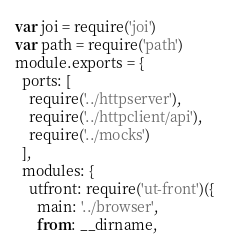Convert code to text. <code><loc_0><loc_0><loc_500><loc_500><_JavaScript_>var joi = require('joi')
var path = require('path')
module.exports = {
  ports: [
    require('../httpserver'),
    require('../httpclient/api'),
    require('../mocks')
  ],
  modules: {
    utfront: require('ut-front')({
      main: '../browser',
      from: __dirname,</code> 